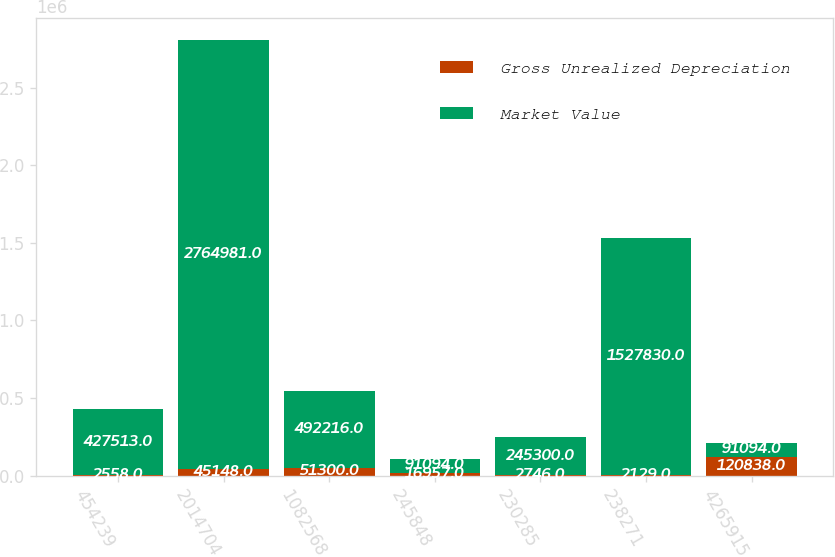Convert chart to OTSL. <chart><loc_0><loc_0><loc_500><loc_500><stacked_bar_chart><ecel><fcel>454239<fcel>2014704<fcel>1082568<fcel>245848<fcel>230285<fcel>238271<fcel>4265915<nl><fcel>Gross Unrealized Depreciation<fcel>2558<fcel>45148<fcel>51300<fcel>16957<fcel>2746<fcel>2129<fcel>120838<nl><fcel>Market Value<fcel>427513<fcel>2.76498e+06<fcel>492216<fcel>91094<fcel>245300<fcel>1.52783e+06<fcel>91094<nl></chart> 